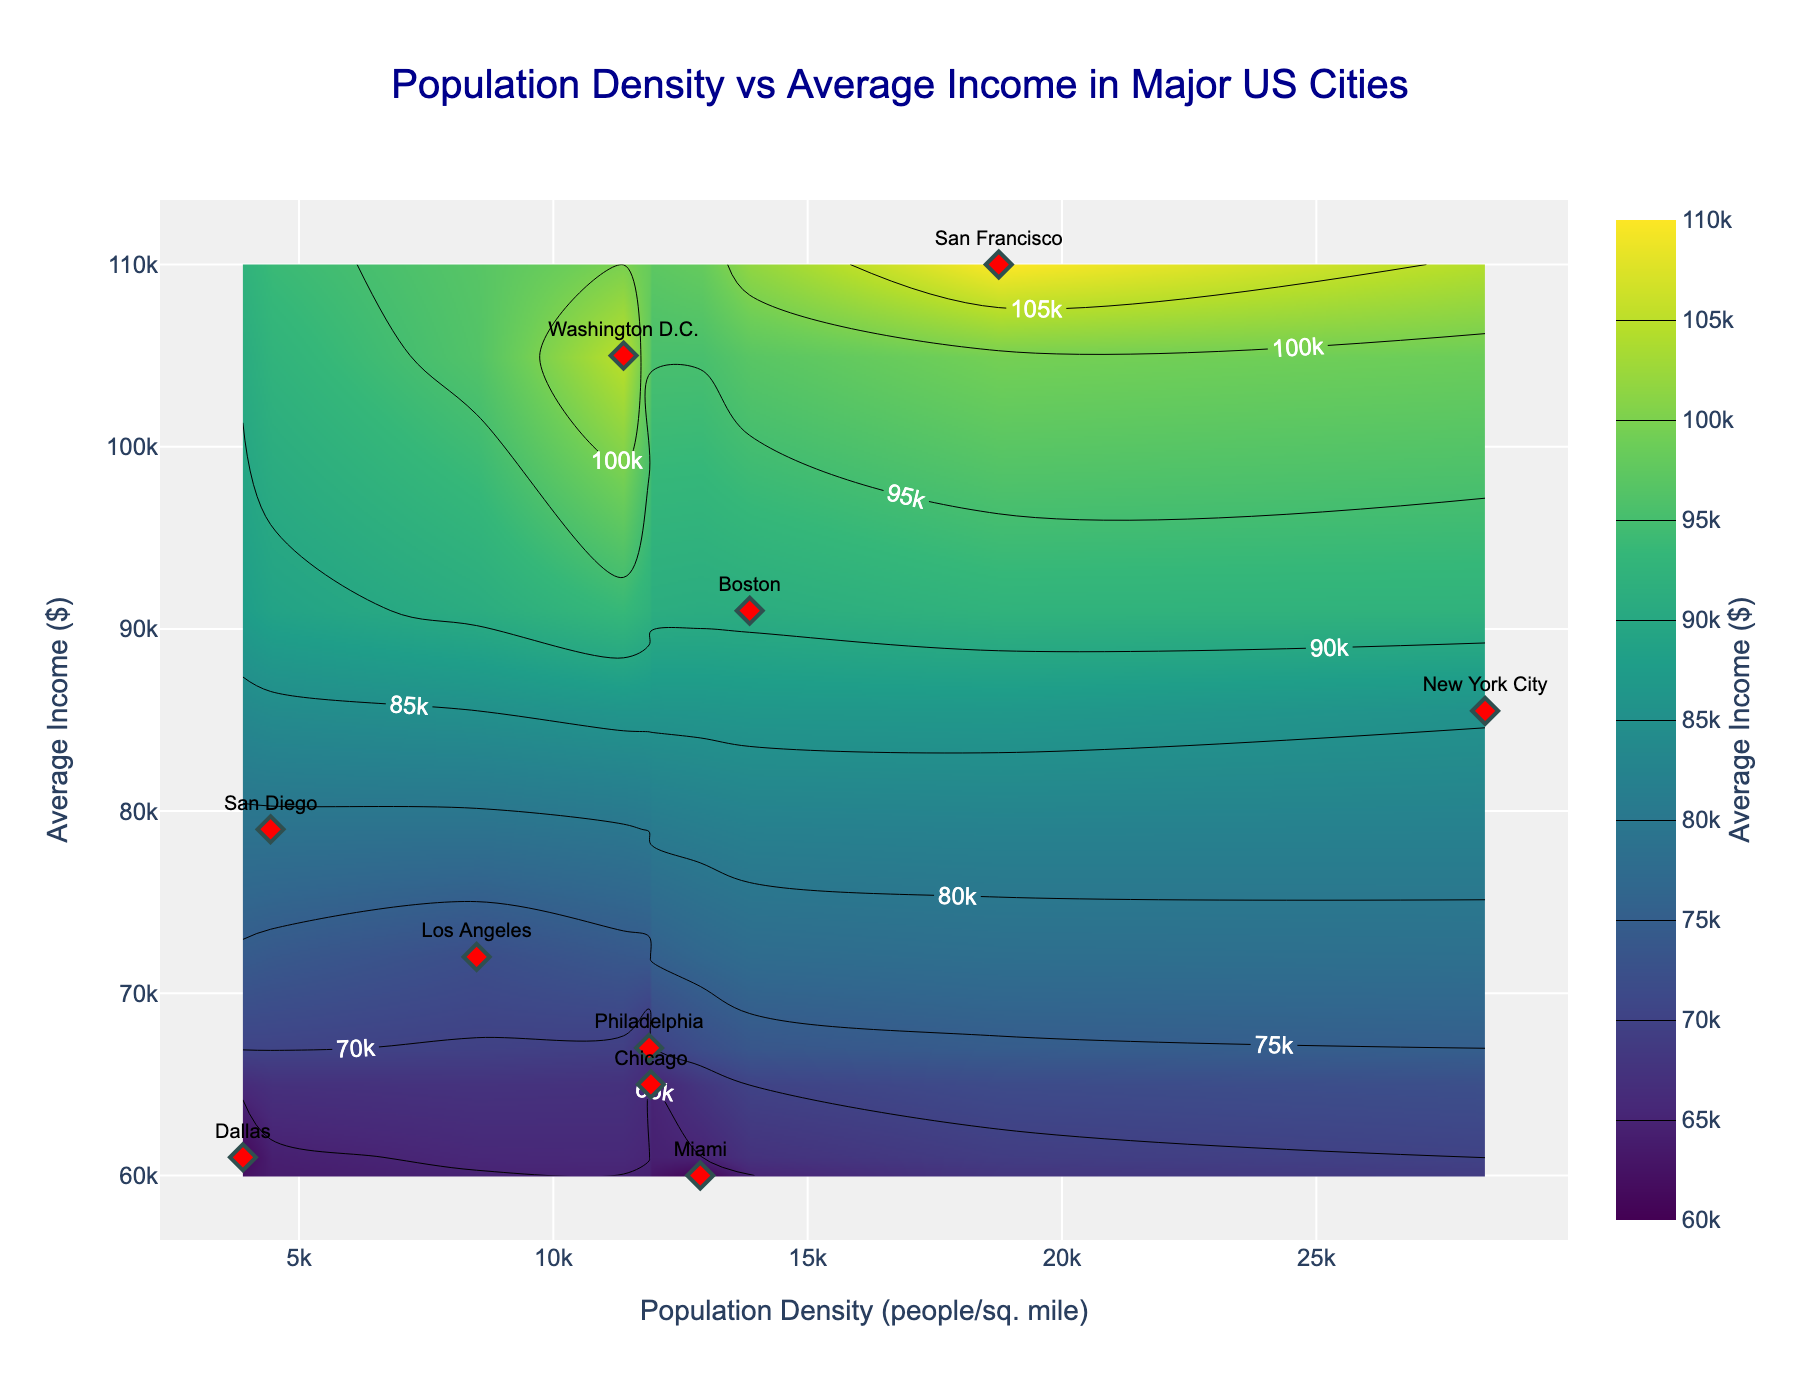How many data points are present in the figure? The figure contains labeled scatter points representing each city. By counting each labeled data point, we can determine the total.
Answer: 10 What is the title of the plot? The title is usually located at the top center of the plot, written in a larger and possibly bold font.
Answer: Population Density vs Average Income in Major US Cities Which city has the highest average income? From the contour plot, identify the point with the highest y-value (average income) and check the label next to it.
Answer: San Francisco Compare the population density of New York City and San Francisco. Which one is higher? Locate the points for New York City and San Francisco. Compare their x-values to see which is farther to the right.
Answer: New York City What are the axes titles in the plot? The axes titles are located along the x-axis and y-axis in the plot. They describe what each axis represents.
Answer: Population Density (people/sq. mile) and Average Income ($) Which city has a lower average income level: Chicago or Philadelphia? Find and compare the y-values of the points labeled Chicago and Philadelphia.
Answer: Chicago What is the color scale used in the contour plot? The color scale represents the contour levels, and it can be identified by the accompanying color bar.
Answer: Viridis Which city has the lowest population density? Identify the point with the smallest x-value and check the corresponding label.
Answer: Dallas Find the difference in average income between Miami and Boston. Locate the points for Miami and Boston, note their y-values (average incomes), and subtract the smaller value from the larger one.
Answer: $31,000 Are there any cities with similar population densities but different income levels? If so, which cities? Look for cities with close x-values but distinct y-values.
Answer: Chicago and Philadelphia Which city lies at the intersection closest to the x-value of 10000 and y-value of 80000? Identify the point whose coordinates are nearest to (10000, 80000) using the scatter plot and their labels.
Answer: Boston 